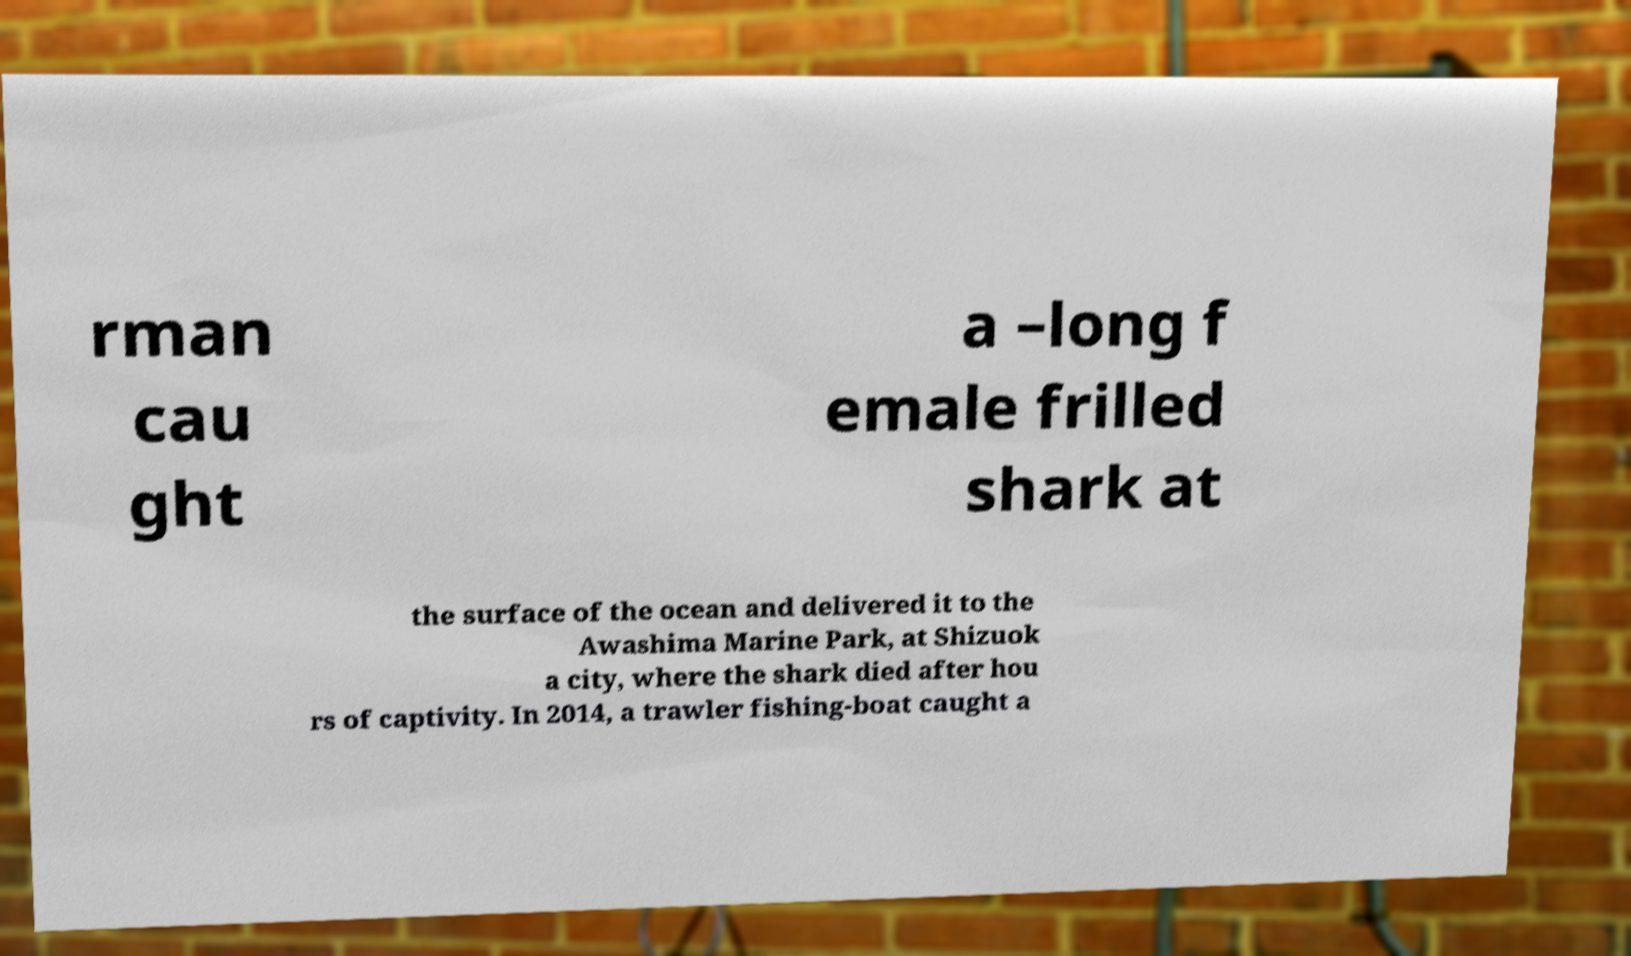I need the written content from this picture converted into text. Can you do that? rman cau ght a –long f emale frilled shark at the surface of the ocean and delivered it to the Awashima Marine Park, at Shizuok a city, where the shark died after hou rs of captivity. In 2014, a trawler fishing-boat caught a 